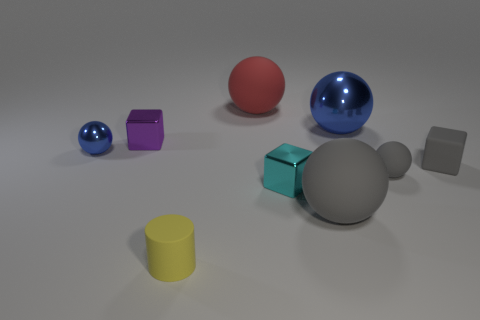Subtract 1 blocks. How many blocks are left? 2 Subtract all gray balls. How many balls are left? 3 Subtract all tiny matte balls. How many balls are left? 4 Subtract all red balls. Subtract all brown cylinders. How many balls are left? 4 Add 5 tiny blue rubber spheres. How many tiny blue rubber spheres exist? 5 Subtract 1 cyan cubes. How many objects are left? 8 Subtract all cubes. How many objects are left? 6 Subtract all gray rubber blocks. Subtract all matte balls. How many objects are left? 5 Add 1 spheres. How many spheres are left? 6 